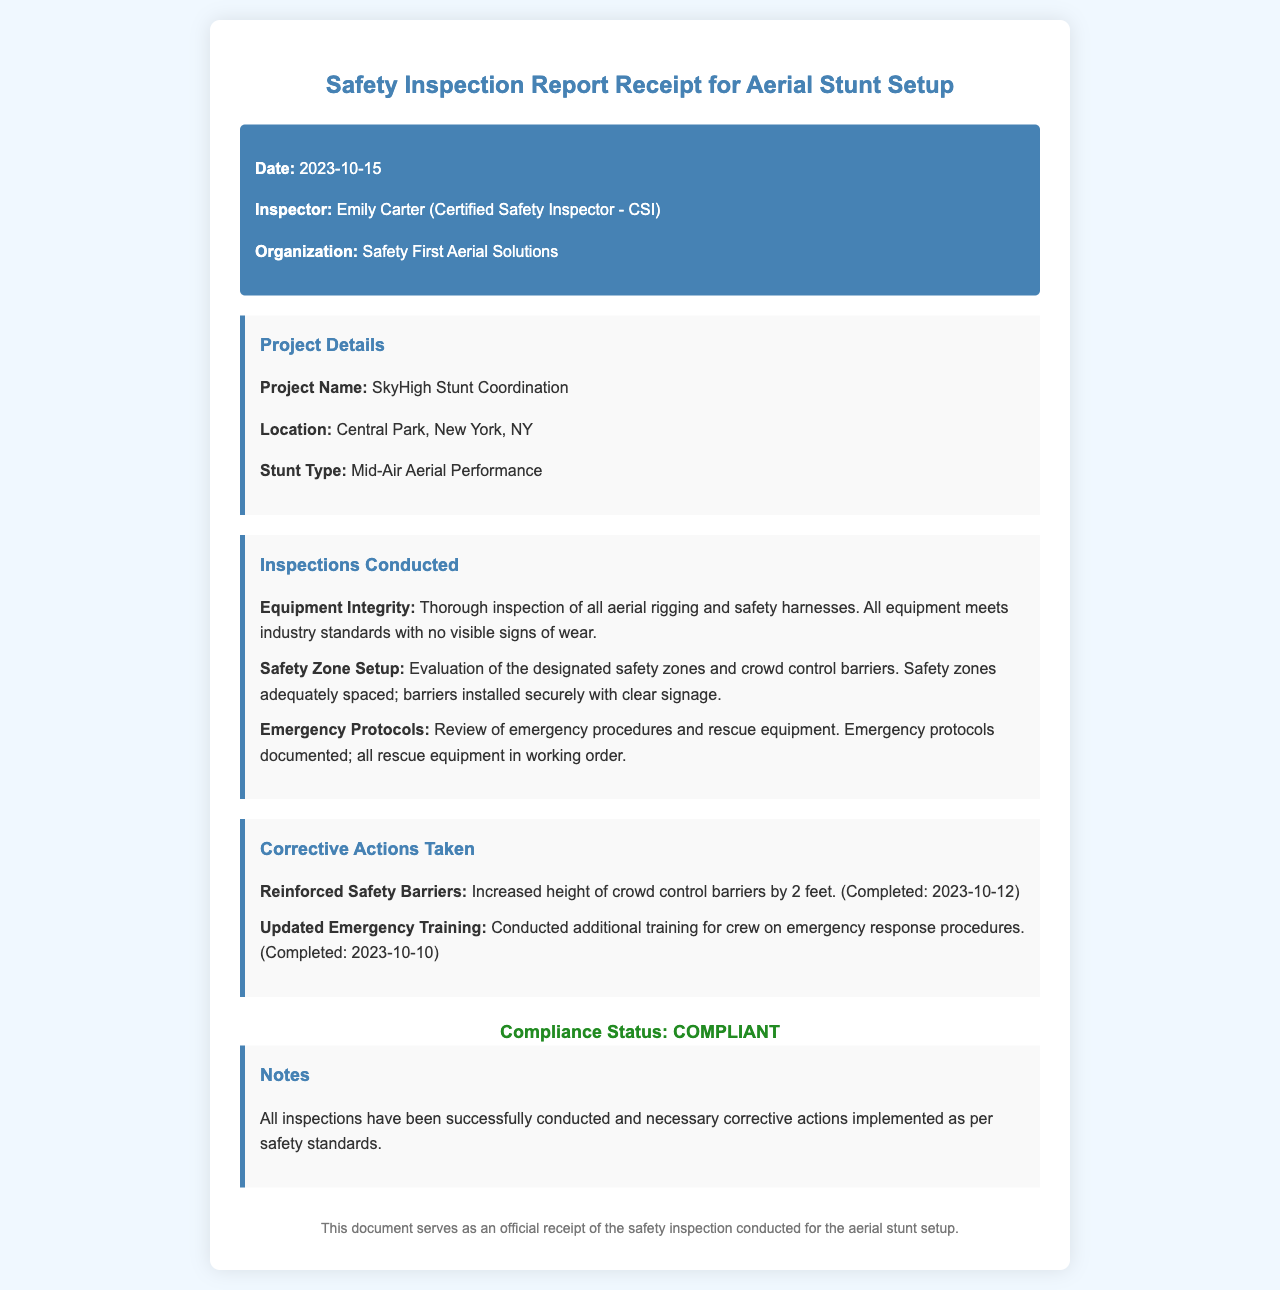What is the date of the inspection? The inspection date is listed prominently in the header section of the document.
Answer: 2023-10-15 Who is the inspector? The document specifies the name and title of the inspector in the header section.
Answer: Emily Carter What is the name of the organization? The name of the organization conducting the inspection is provided in the header section.
Answer: Safety First Aerial Solutions What is the project location? The project location is mentioned in the project details section of the document.
Answer: Central Park, New York, NY What stunt type is being coordinated? The document provides the specific type of stunt being performed in the project details section.
Answer: Mid-Air Aerial Performance How many inspections were conducted? The inspections conducted section lists three specific inspections, indicating the total count.
Answer: Three What was one of the corrective actions taken? The corrective actions section lists actions that were completed, providing examples of changes made.
Answer: Reinforced Safety Barriers What was the compliance status? The compliance status is clearly stated in a designated section towards the bottom of the document.
Answer: COMPLIANT Why was additional training conducted? The reason for the additional training is implied in the context of safety protocols and preparedness.
Answer: Emergency response procedures 